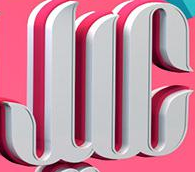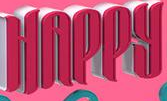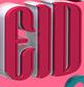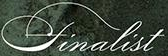Read the text content from these images in order, separated by a semicolon. JIC; HAPPY; EID; finalist 